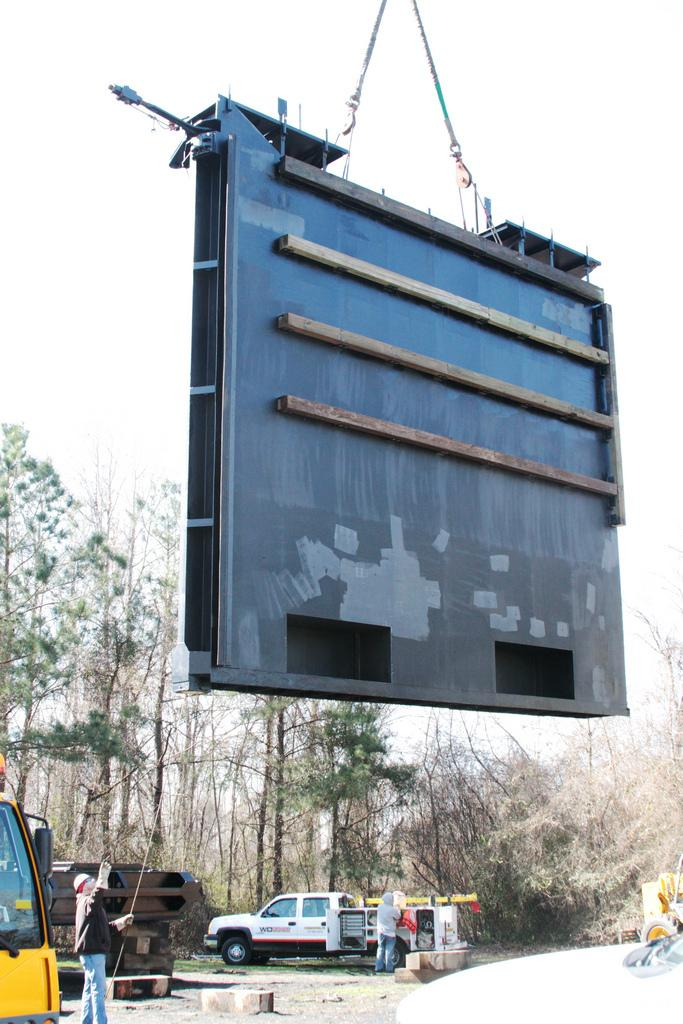What can be seen in the image involving people? There are people standing in the image. What else is present in the image besides people? There are vehicles and trees in the image. Are there any specific types of trees mentioned in the image? Yes, there are both trees and dried trees in the image. What is located in the middle of the image? There is an object in the middle of the image. What is visible at the top of the image? The sky is visible at the top of the image. What is the wind doing to the people's desires in the image? There is no mention of wind or desires in the image; it only shows people standing, vehicles, trees, dried trees, an object in the middle, and the sky. Is there a roof visible in the image? There is no mention of a roof in the image; it only shows people standing, vehicles, trees, dried trees, an object in the middle, and the sky. 